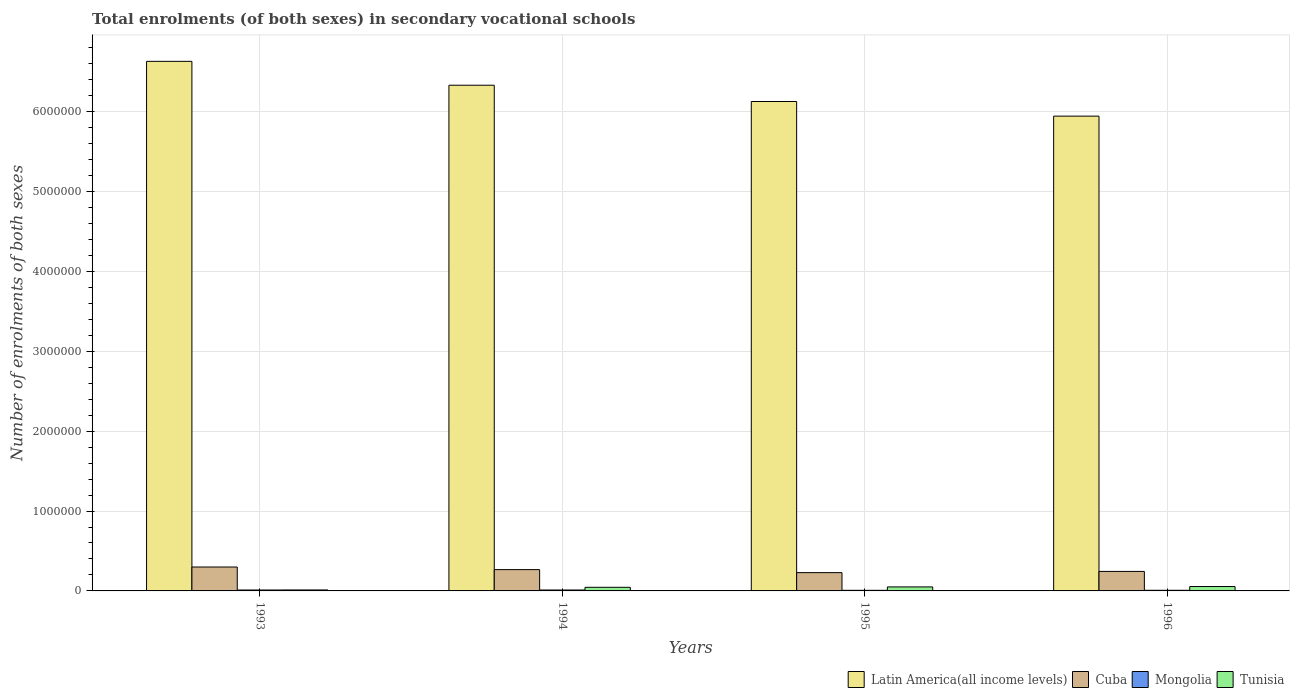How many different coloured bars are there?
Give a very brief answer. 4. How many groups of bars are there?
Your answer should be very brief. 4. Are the number of bars per tick equal to the number of legend labels?
Make the answer very short. Yes. How many bars are there on the 4th tick from the right?
Offer a terse response. 4. In how many cases, is the number of bars for a given year not equal to the number of legend labels?
Offer a very short reply. 0. What is the number of enrolments in secondary schools in Mongolia in 1996?
Your answer should be compact. 7987. Across all years, what is the maximum number of enrolments in secondary schools in Tunisia?
Provide a short and direct response. 5.50e+04. Across all years, what is the minimum number of enrolments in secondary schools in Mongolia?
Make the answer very short. 7555. In which year was the number of enrolments in secondary schools in Latin America(all income levels) maximum?
Make the answer very short. 1993. What is the total number of enrolments in secondary schools in Latin America(all income levels) in the graph?
Provide a succinct answer. 2.50e+07. What is the difference between the number of enrolments in secondary schools in Cuba in 1994 and that in 1996?
Offer a terse response. 2.24e+04. What is the difference between the number of enrolments in secondary schools in Tunisia in 1996 and the number of enrolments in secondary schools in Mongolia in 1994?
Give a very brief answer. 4.35e+04. What is the average number of enrolments in secondary schools in Cuba per year?
Your response must be concise. 2.60e+05. In the year 1993, what is the difference between the number of enrolments in secondary schools in Mongolia and number of enrolments in secondary schools in Latin America(all income levels)?
Provide a succinct answer. -6.62e+06. In how many years, is the number of enrolments in secondary schools in Latin America(all income levels) greater than 1000000?
Your answer should be compact. 4. What is the ratio of the number of enrolments in secondary schools in Cuba in 1993 to that in 1994?
Provide a short and direct response. 1.12. Is the number of enrolments in secondary schools in Cuba in 1994 less than that in 1995?
Give a very brief answer. No. What is the difference between the highest and the second highest number of enrolments in secondary schools in Tunisia?
Provide a succinct answer. 4798. What is the difference between the highest and the lowest number of enrolments in secondary schools in Latin America(all income levels)?
Offer a terse response. 6.86e+05. In how many years, is the number of enrolments in secondary schools in Cuba greater than the average number of enrolments in secondary schools in Cuba taken over all years?
Your response must be concise. 2. Is the sum of the number of enrolments in secondary schools in Tunisia in 1994 and 1995 greater than the maximum number of enrolments in secondary schools in Cuba across all years?
Your response must be concise. No. What does the 2nd bar from the left in 1994 represents?
Your response must be concise. Cuba. What does the 4th bar from the right in 1994 represents?
Give a very brief answer. Latin America(all income levels). How many bars are there?
Offer a very short reply. 16. Are all the bars in the graph horizontal?
Ensure brevity in your answer.  No. How many years are there in the graph?
Your answer should be compact. 4. What is the difference between two consecutive major ticks on the Y-axis?
Give a very brief answer. 1.00e+06. Does the graph contain any zero values?
Your answer should be compact. No. Where does the legend appear in the graph?
Your response must be concise. Bottom right. What is the title of the graph?
Offer a very short reply. Total enrolments (of both sexes) in secondary vocational schools. What is the label or title of the X-axis?
Your answer should be very brief. Years. What is the label or title of the Y-axis?
Make the answer very short. Number of enrolments of both sexes. What is the Number of enrolments of both sexes of Latin America(all income levels) in 1993?
Offer a terse response. 6.63e+06. What is the Number of enrolments of both sexes in Cuba in 1993?
Offer a very short reply. 2.99e+05. What is the Number of enrolments of both sexes in Mongolia in 1993?
Give a very brief answer. 1.15e+04. What is the Number of enrolments of both sexes of Tunisia in 1993?
Keep it short and to the point. 1.21e+04. What is the Number of enrolments of both sexes in Latin America(all income levels) in 1994?
Provide a short and direct response. 6.33e+06. What is the Number of enrolments of both sexes in Cuba in 1994?
Provide a succinct answer. 2.67e+05. What is the Number of enrolments of both sexes of Mongolia in 1994?
Make the answer very short. 1.15e+04. What is the Number of enrolments of both sexes of Tunisia in 1994?
Offer a very short reply. 4.52e+04. What is the Number of enrolments of both sexes in Latin America(all income levels) in 1995?
Keep it short and to the point. 6.13e+06. What is the Number of enrolments of both sexes in Cuba in 1995?
Offer a terse response. 2.29e+05. What is the Number of enrolments of both sexes in Mongolia in 1995?
Make the answer very short. 7555. What is the Number of enrolments of both sexes of Tunisia in 1995?
Your response must be concise. 5.02e+04. What is the Number of enrolments of both sexes in Latin America(all income levels) in 1996?
Make the answer very short. 5.94e+06. What is the Number of enrolments of both sexes in Cuba in 1996?
Offer a very short reply. 2.44e+05. What is the Number of enrolments of both sexes in Mongolia in 1996?
Make the answer very short. 7987. What is the Number of enrolments of both sexes of Tunisia in 1996?
Offer a terse response. 5.50e+04. Across all years, what is the maximum Number of enrolments of both sexes in Latin America(all income levels)?
Offer a very short reply. 6.63e+06. Across all years, what is the maximum Number of enrolments of both sexes of Cuba?
Keep it short and to the point. 2.99e+05. Across all years, what is the maximum Number of enrolments of both sexes of Mongolia?
Ensure brevity in your answer.  1.15e+04. Across all years, what is the maximum Number of enrolments of both sexes of Tunisia?
Give a very brief answer. 5.50e+04. Across all years, what is the minimum Number of enrolments of both sexes of Latin America(all income levels)?
Make the answer very short. 5.94e+06. Across all years, what is the minimum Number of enrolments of both sexes in Cuba?
Offer a terse response. 2.29e+05. Across all years, what is the minimum Number of enrolments of both sexes in Mongolia?
Your response must be concise. 7555. Across all years, what is the minimum Number of enrolments of both sexes of Tunisia?
Provide a succinct answer. 1.21e+04. What is the total Number of enrolments of both sexes in Latin America(all income levels) in the graph?
Your answer should be compact. 2.50e+07. What is the total Number of enrolments of both sexes in Cuba in the graph?
Keep it short and to the point. 1.04e+06. What is the total Number of enrolments of both sexes in Mongolia in the graph?
Offer a very short reply. 3.85e+04. What is the total Number of enrolments of both sexes of Tunisia in the graph?
Your answer should be very brief. 1.62e+05. What is the difference between the Number of enrolments of both sexes in Latin America(all income levels) in 1993 and that in 1994?
Ensure brevity in your answer.  2.99e+05. What is the difference between the Number of enrolments of both sexes in Cuba in 1993 and that in 1994?
Offer a terse response. 3.28e+04. What is the difference between the Number of enrolments of both sexes of Mongolia in 1993 and that in 1994?
Offer a very short reply. 0. What is the difference between the Number of enrolments of both sexes of Tunisia in 1993 and that in 1994?
Offer a very short reply. -3.30e+04. What is the difference between the Number of enrolments of both sexes in Latin America(all income levels) in 1993 and that in 1995?
Offer a terse response. 5.02e+05. What is the difference between the Number of enrolments of both sexes in Cuba in 1993 and that in 1995?
Ensure brevity in your answer.  7.04e+04. What is the difference between the Number of enrolments of both sexes of Mongolia in 1993 and that in 1995?
Make the answer very short. 3936. What is the difference between the Number of enrolments of both sexes in Tunisia in 1993 and that in 1995?
Ensure brevity in your answer.  -3.80e+04. What is the difference between the Number of enrolments of both sexes in Latin America(all income levels) in 1993 and that in 1996?
Your response must be concise. 6.86e+05. What is the difference between the Number of enrolments of both sexes in Cuba in 1993 and that in 1996?
Make the answer very short. 5.52e+04. What is the difference between the Number of enrolments of both sexes of Mongolia in 1993 and that in 1996?
Make the answer very short. 3504. What is the difference between the Number of enrolments of both sexes of Tunisia in 1993 and that in 1996?
Offer a terse response. -4.28e+04. What is the difference between the Number of enrolments of both sexes of Latin America(all income levels) in 1994 and that in 1995?
Your answer should be very brief. 2.04e+05. What is the difference between the Number of enrolments of both sexes in Cuba in 1994 and that in 1995?
Provide a succinct answer. 3.77e+04. What is the difference between the Number of enrolments of both sexes of Mongolia in 1994 and that in 1995?
Offer a terse response. 3936. What is the difference between the Number of enrolments of both sexes of Tunisia in 1994 and that in 1995?
Your answer should be very brief. -4986. What is the difference between the Number of enrolments of both sexes in Latin America(all income levels) in 1994 and that in 1996?
Offer a very short reply. 3.87e+05. What is the difference between the Number of enrolments of both sexes of Cuba in 1994 and that in 1996?
Your answer should be compact. 2.24e+04. What is the difference between the Number of enrolments of both sexes of Mongolia in 1994 and that in 1996?
Offer a very short reply. 3504. What is the difference between the Number of enrolments of both sexes in Tunisia in 1994 and that in 1996?
Give a very brief answer. -9784. What is the difference between the Number of enrolments of both sexes in Latin America(all income levels) in 1995 and that in 1996?
Offer a very short reply. 1.83e+05. What is the difference between the Number of enrolments of both sexes in Cuba in 1995 and that in 1996?
Provide a succinct answer. -1.53e+04. What is the difference between the Number of enrolments of both sexes in Mongolia in 1995 and that in 1996?
Your response must be concise. -432. What is the difference between the Number of enrolments of both sexes in Tunisia in 1995 and that in 1996?
Provide a succinct answer. -4798. What is the difference between the Number of enrolments of both sexes of Latin America(all income levels) in 1993 and the Number of enrolments of both sexes of Cuba in 1994?
Keep it short and to the point. 6.36e+06. What is the difference between the Number of enrolments of both sexes of Latin America(all income levels) in 1993 and the Number of enrolments of both sexes of Mongolia in 1994?
Keep it short and to the point. 6.62e+06. What is the difference between the Number of enrolments of both sexes of Latin America(all income levels) in 1993 and the Number of enrolments of both sexes of Tunisia in 1994?
Your answer should be very brief. 6.58e+06. What is the difference between the Number of enrolments of both sexes in Cuba in 1993 and the Number of enrolments of both sexes in Mongolia in 1994?
Your answer should be compact. 2.88e+05. What is the difference between the Number of enrolments of both sexes of Cuba in 1993 and the Number of enrolments of both sexes of Tunisia in 1994?
Offer a terse response. 2.54e+05. What is the difference between the Number of enrolments of both sexes in Mongolia in 1993 and the Number of enrolments of both sexes in Tunisia in 1994?
Your response must be concise. -3.37e+04. What is the difference between the Number of enrolments of both sexes of Latin America(all income levels) in 1993 and the Number of enrolments of both sexes of Cuba in 1995?
Ensure brevity in your answer.  6.40e+06. What is the difference between the Number of enrolments of both sexes of Latin America(all income levels) in 1993 and the Number of enrolments of both sexes of Mongolia in 1995?
Your answer should be compact. 6.62e+06. What is the difference between the Number of enrolments of both sexes of Latin America(all income levels) in 1993 and the Number of enrolments of both sexes of Tunisia in 1995?
Your response must be concise. 6.58e+06. What is the difference between the Number of enrolments of both sexes in Cuba in 1993 and the Number of enrolments of both sexes in Mongolia in 1995?
Keep it short and to the point. 2.92e+05. What is the difference between the Number of enrolments of both sexes of Cuba in 1993 and the Number of enrolments of both sexes of Tunisia in 1995?
Keep it short and to the point. 2.49e+05. What is the difference between the Number of enrolments of both sexes of Mongolia in 1993 and the Number of enrolments of both sexes of Tunisia in 1995?
Provide a short and direct response. -3.87e+04. What is the difference between the Number of enrolments of both sexes of Latin America(all income levels) in 1993 and the Number of enrolments of both sexes of Cuba in 1996?
Provide a short and direct response. 6.39e+06. What is the difference between the Number of enrolments of both sexes of Latin America(all income levels) in 1993 and the Number of enrolments of both sexes of Mongolia in 1996?
Offer a very short reply. 6.62e+06. What is the difference between the Number of enrolments of both sexes of Latin America(all income levels) in 1993 and the Number of enrolments of both sexes of Tunisia in 1996?
Keep it short and to the point. 6.57e+06. What is the difference between the Number of enrolments of both sexes in Cuba in 1993 and the Number of enrolments of both sexes in Mongolia in 1996?
Your response must be concise. 2.91e+05. What is the difference between the Number of enrolments of both sexes of Cuba in 1993 and the Number of enrolments of both sexes of Tunisia in 1996?
Offer a terse response. 2.44e+05. What is the difference between the Number of enrolments of both sexes of Mongolia in 1993 and the Number of enrolments of both sexes of Tunisia in 1996?
Provide a short and direct response. -4.35e+04. What is the difference between the Number of enrolments of both sexes in Latin America(all income levels) in 1994 and the Number of enrolments of both sexes in Cuba in 1995?
Your response must be concise. 6.10e+06. What is the difference between the Number of enrolments of both sexes of Latin America(all income levels) in 1994 and the Number of enrolments of both sexes of Mongolia in 1995?
Keep it short and to the point. 6.32e+06. What is the difference between the Number of enrolments of both sexes of Latin America(all income levels) in 1994 and the Number of enrolments of both sexes of Tunisia in 1995?
Your answer should be compact. 6.28e+06. What is the difference between the Number of enrolments of both sexes of Cuba in 1994 and the Number of enrolments of both sexes of Mongolia in 1995?
Provide a succinct answer. 2.59e+05. What is the difference between the Number of enrolments of both sexes in Cuba in 1994 and the Number of enrolments of both sexes in Tunisia in 1995?
Give a very brief answer. 2.16e+05. What is the difference between the Number of enrolments of both sexes in Mongolia in 1994 and the Number of enrolments of both sexes in Tunisia in 1995?
Provide a short and direct response. -3.87e+04. What is the difference between the Number of enrolments of both sexes in Latin America(all income levels) in 1994 and the Number of enrolments of both sexes in Cuba in 1996?
Ensure brevity in your answer.  6.09e+06. What is the difference between the Number of enrolments of both sexes of Latin America(all income levels) in 1994 and the Number of enrolments of both sexes of Mongolia in 1996?
Your answer should be very brief. 6.32e+06. What is the difference between the Number of enrolments of both sexes in Latin America(all income levels) in 1994 and the Number of enrolments of both sexes in Tunisia in 1996?
Provide a short and direct response. 6.28e+06. What is the difference between the Number of enrolments of both sexes of Cuba in 1994 and the Number of enrolments of both sexes of Mongolia in 1996?
Offer a terse response. 2.59e+05. What is the difference between the Number of enrolments of both sexes of Cuba in 1994 and the Number of enrolments of both sexes of Tunisia in 1996?
Keep it short and to the point. 2.12e+05. What is the difference between the Number of enrolments of both sexes in Mongolia in 1994 and the Number of enrolments of both sexes in Tunisia in 1996?
Keep it short and to the point. -4.35e+04. What is the difference between the Number of enrolments of both sexes in Latin America(all income levels) in 1995 and the Number of enrolments of both sexes in Cuba in 1996?
Give a very brief answer. 5.88e+06. What is the difference between the Number of enrolments of both sexes in Latin America(all income levels) in 1995 and the Number of enrolments of both sexes in Mongolia in 1996?
Keep it short and to the point. 6.12e+06. What is the difference between the Number of enrolments of both sexes in Latin America(all income levels) in 1995 and the Number of enrolments of both sexes in Tunisia in 1996?
Your answer should be very brief. 6.07e+06. What is the difference between the Number of enrolments of both sexes in Cuba in 1995 and the Number of enrolments of both sexes in Mongolia in 1996?
Give a very brief answer. 2.21e+05. What is the difference between the Number of enrolments of both sexes in Cuba in 1995 and the Number of enrolments of both sexes in Tunisia in 1996?
Ensure brevity in your answer.  1.74e+05. What is the difference between the Number of enrolments of both sexes in Mongolia in 1995 and the Number of enrolments of both sexes in Tunisia in 1996?
Your response must be concise. -4.74e+04. What is the average Number of enrolments of both sexes in Latin America(all income levels) per year?
Offer a very short reply. 6.26e+06. What is the average Number of enrolments of both sexes of Cuba per year?
Provide a succinct answer. 2.60e+05. What is the average Number of enrolments of both sexes in Mongolia per year?
Provide a succinct answer. 9631. What is the average Number of enrolments of both sexes in Tunisia per year?
Offer a terse response. 4.06e+04. In the year 1993, what is the difference between the Number of enrolments of both sexes in Latin America(all income levels) and Number of enrolments of both sexes in Cuba?
Keep it short and to the point. 6.33e+06. In the year 1993, what is the difference between the Number of enrolments of both sexes in Latin America(all income levels) and Number of enrolments of both sexes in Mongolia?
Provide a succinct answer. 6.62e+06. In the year 1993, what is the difference between the Number of enrolments of both sexes of Latin America(all income levels) and Number of enrolments of both sexes of Tunisia?
Your response must be concise. 6.62e+06. In the year 1993, what is the difference between the Number of enrolments of both sexes in Cuba and Number of enrolments of both sexes in Mongolia?
Offer a terse response. 2.88e+05. In the year 1993, what is the difference between the Number of enrolments of both sexes of Cuba and Number of enrolments of both sexes of Tunisia?
Give a very brief answer. 2.87e+05. In the year 1993, what is the difference between the Number of enrolments of both sexes in Mongolia and Number of enrolments of both sexes in Tunisia?
Provide a short and direct response. -657. In the year 1994, what is the difference between the Number of enrolments of both sexes in Latin America(all income levels) and Number of enrolments of both sexes in Cuba?
Offer a very short reply. 6.06e+06. In the year 1994, what is the difference between the Number of enrolments of both sexes in Latin America(all income levels) and Number of enrolments of both sexes in Mongolia?
Your answer should be very brief. 6.32e+06. In the year 1994, what is the difference between the Number of enrolments of both sexes in Latin America(all income levels) and Number of enrolments of both sexes in Tunisia?
Make the answer very short. 6.29e+06. In the year 1994, what is the difference between the Number of enrolments of both sexes of Cuba and Number of enrolments of both sexes of Mongolia?
Give a very brief answer. 2.55e+05. In the year 1994, what is the difference between the Number of enrolments of both sexes of Cuba and Number of enrolments of both sexes of Tunisia?
Provide a short and direct response. 2.21e+05. In the year 1994, what is the difference between the Number of enrolments of both sexes in Mongolia and Number of enrolments of both sexes in Tunisia?
Keep it short and to the point. -3.37e+04. In the year 1995, what is the difference between the Number of enrolments of both sexes of Latin America(all income levels) and Number of enrolments of both sexes of Cuba?
Your response must be concise. 5.90e+06. In the year 1995, what is the difference between the Number of enrolments of both sexes of Latin America(all income levels) and Number of enrolments of both sexes of Mongolia?
Give a very brief answer. 6.12e+06. In the year 1995, what is the difference between the Number of enrolments of both sexes in Latin America(all income levels) and Number of enrolments of both sexes in Tunisia?
Provide a succinct answer. 6.08e+06. In the year 1995, what is the difference between the Number of enrolments of both sexes of Cuba and Number of enrolments of both sexes of Mongolia?
Offer a very short reply. 2.21e+05. In the year 1995, what is the difference between the Number of enrolments of both sexes in Cuba and Number of enrolments of both sexes in Tunisia?
Offer a terse response. 1.79e+05. In the year 1995, what is the difference between the Number of enrolments of both sexes of Mongolia and Number of enrolments of both sexes of Tunisia?
Your answer should be very brief. -4.26e+04. In the year 1996, what is the difference between the Number of enrolments of both sexes in Latin America(all income levels) and Number of enrolments of both sexes in Cuba?
Provide a short and direct response. 5.70e+06. In the year 1996, what is the difference between the Number of enrolments of both sexes in Latin America(all income levels) and Number of enrolments of both sexes in Mongolia?
Keep it short and to the point. 5.94e+06. In the year 1996, what is the difference between the Number of enrolments of both sexes in Latin America(all income levels) and Number of enrolments of both sexes in Tunisia?
Your response must be concise. 5.89e+06. In the year 1996, what is the difference between the Number of enrolments of both sexes in Cuba and Number of enrolments of both sexes in Mongolia?
Ensure brevity in your answer.  2.36e+05. In the year 1996, what is the difference between the Number of enrolments of both sexes of Cuba and Number of enrolments of both sexes of Tunisia?
Your answer should be compact. 1.89e+05. In the year 1996, what is the difference between the Number of enrolments of both sexes of Mongolia and Number of enrolments of both sexes of Tunisia?
Offer a terse response. -4.70e+04. What is the ratio of the Number of enrolments of both sexes in Latin America(all income levels) in 1993 to that in 1994?
Provide a succinct answer. 1.05. What is the ratio of the Number of enrolments of both sexes in Cuba in 1993 to that in 1994?
Your answer should be compact. 1.12. What is the ratio of the Number of enrolments of both sexes in Mongolia in 1993 to that in 1994?
Your response must be concise. 1. What is the ratio of the Number of enrolments of both sexes of Tunisia in 1993 to that in 1994?
Provide a succinct answer. 0.27. What is the ratio of the Number of enrolments of both sexes of Latin America(all income levels) in 1993 to that in 1995?
Keep it short and to the point. 1.08. What is the ratio of the Number of enrolments of both sexes in Cuba in 1993 to that in 1995?
Keep it short and to the point. 1.31. What is the ratio of the Number of enrolments of both sexes in Mongolia in 1993 to that in 1995?
Your answer should be compact. 1.52. What is the ratio of the Number of enrolments of both sexes of Tunisia in 1993 to that in 1995?
Provide a short and direct response. 0.24. What is the ratio of the Number of enrolments of both sexes in Latin America(all income levels) in 1993 to that in 1996?
Provide a succinct answer. 1.12. What is the ratio of the Number of enrolments of both sexes of Cuba in 1993 to that in 1996?
Make the answer very short. 1.23. What is the ratio of the Number of enrolments of both sexes in Mongolia in 1993 to that in 1996?
Give a very brief answer. 1.44. What is the ratio of the Number of enrolments of both sexes in Tunisia in 1993 to that in 1996?
Keep it short and to the point. 0.22. What is the ratio of the Number of enrolments of both sexes in Latin America(all income levels) in 1994 to that in 1995?
Your response must be concise. 1.03. What is the ratio of the Number of enrolments of both sexes in Cuba in 1994 to that in 1995?
Keep it short and to the point. 1.16. What is the ratio of the Number of enrolments of both sexes in Mongolia in 1994 to that in 1995?
Offer a very short reply. 1.52. What is the ratio of the Number of enrolments of both sexes in Tunisia in 1994 to that in 1995?
Your response must be concise. 0.9. What is the ratio of the Number of enrolments of both sexes in Latin America(all income levels) in 1994 to that in 1996?
Your response must be concise. 1.07. What is the ratio of the Number of enrolments of both sexes in Cuba in 1994 to that in 1996?
Provide a succinct answer. 1.09. What is the ratio of the Number of enrolments of both sexes of Mongolia in 1994 to that in 1996?
Give a very brief answer. 1.44. What is the ratio of the Number of enrolments of both sexes of Tunisia in 1994 to that in 1996?
Your answer should be compact. 0.82. What is the ratio of the Number of enrolments of both sexes of Latin America(all income levels) in 1995 to that in 1996?
Offer a terse response. 1.03. What is the ratio of the Number of enrolments of both sexes of Cuba in 1995 to that in 1996?
Keep it short and to the point. 0.94. What is the ratio of the Number of enrolments of both sexes of Mongolia in 1995 to that in 1996?
Ensure brevity in your answer.  0.95. What is the ratio of the Number of enrolments of both sexes of Tunisia in 1995 to that in 1996?
Your answer should be compact. 0.91. What is the difference between the highest and the second highest Number of enrolments of both sexes of Latin America(all income levels)?
Offer a terse response. 2.99e+05. What is the difference between the highest and the second highest Number of enrolments of both sexes in Cuba?
Offer a very short reply. 3.28e+04. What is the difference between the highest and the second highest Number of enrolments of both sexes in Mongolia?
Your answer should be very brief. 0. What is the difference between the highest and the second highest Number of enrolments of both sexes in Tunisia?
Offer a very short reply. 4798. What is the difference between the highest and the lowest Number of enrolments of both sexes in Latin America(all income levels)?
Make the answer very short. 6.86e+05. What is the difference between the highest and the lowest Number of enrolments of both sexes of Cuba?
Offer a terse response. 7.04e+04. What is the difference between the highest and the lowest Number of enrolments of both sexes in Mongolia?
Provide a short and direct response. 3936. What is the difference between the highest and the lowest Number of enrolments of both sexes of Tunisia?
Your answer should be very brief. 4.28e+04. 